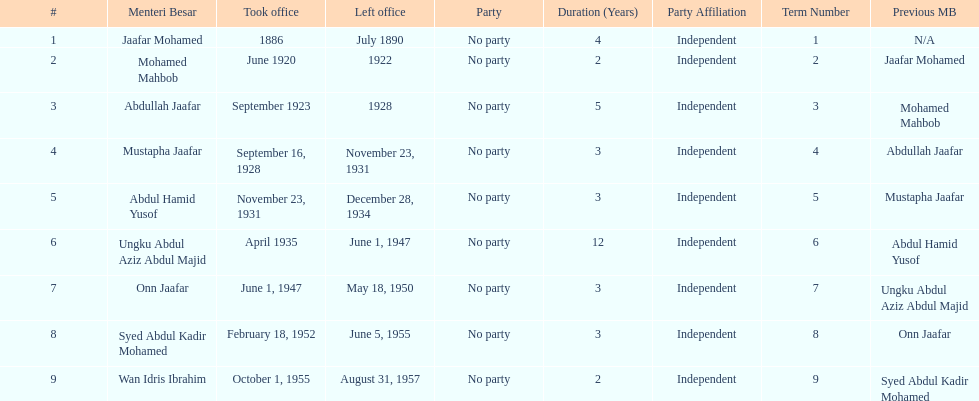Who was the first to take office? Jaafar Mohamed. 